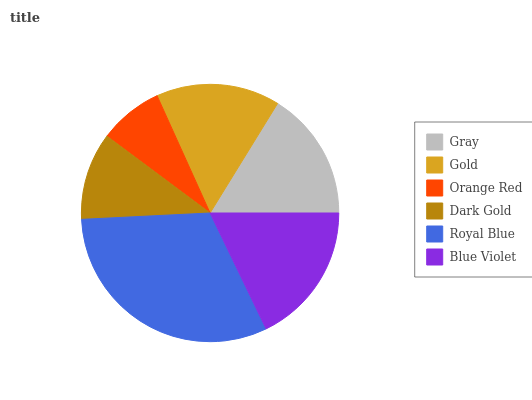Is Orange Red the minimum?
Answer yes or no. Yes. Is Royal Blue the maximum?
Answer yes or no. Yes. Is Gold the minimum?
Answer yes or no. No. Is Gold the maximum?
Answer yes or no. No. Is Gray greater than Gold?
Answer yes or no. Yes. Is Gold less than Gray?
Answer yes or no. Yes. Is Gold greater than Gray?
Answer yes or no. No. Is Gray less than Gold?
Answer yes or no. No. Is Gray the high median?
Answer yes or no. Yes. Is Gold the low median?
Answer yes or no. Yes. Is Blue Violet the high median?
Answer yes or no. No. Is Dark Gold the low median?
Answer yes or no. No. 